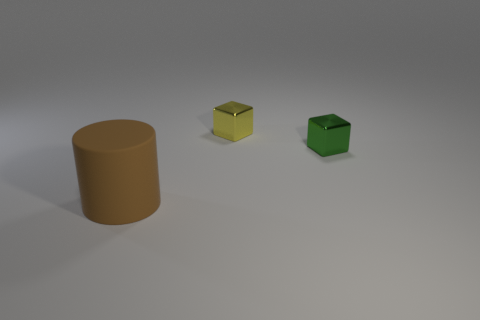Add 1 tiny yellow shiny blocks. How many objects exist? 4 Subtract all cubes. How many objects are left? 1 Subtract 0 gray spheres. How many objects are left? 3 Subtract all brown cylinders. Subtract all rubber things. How many objects are left? 1 Add 3 tiny yellow blocks. How many tiny yellow blocks are left? 4 Add 3 large gray balls. How many large gray balls exist? 3 